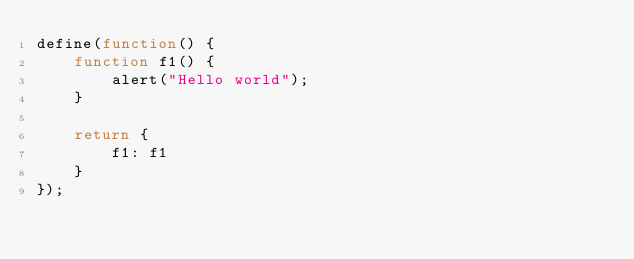Convert code to text. <code><loc_0><loc_0><loc_500><loc_500><_JavaScript_>define(function() {
    function f1() {
        alert("Hello world");
    }

    return {
        f1: f1
    }
});</code> 